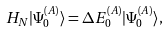Convert formula to latex. <formula><loc_0><loc_0><loc_500><loc_500>H _ { N } | \Psi _ { 0 } ^ { ( A ) } \rangle = \Delta E _ { 0 } ^ { ( A ) } | \Psi _ { 0 } ^ { ( A ) } \rangle ,</formula> 